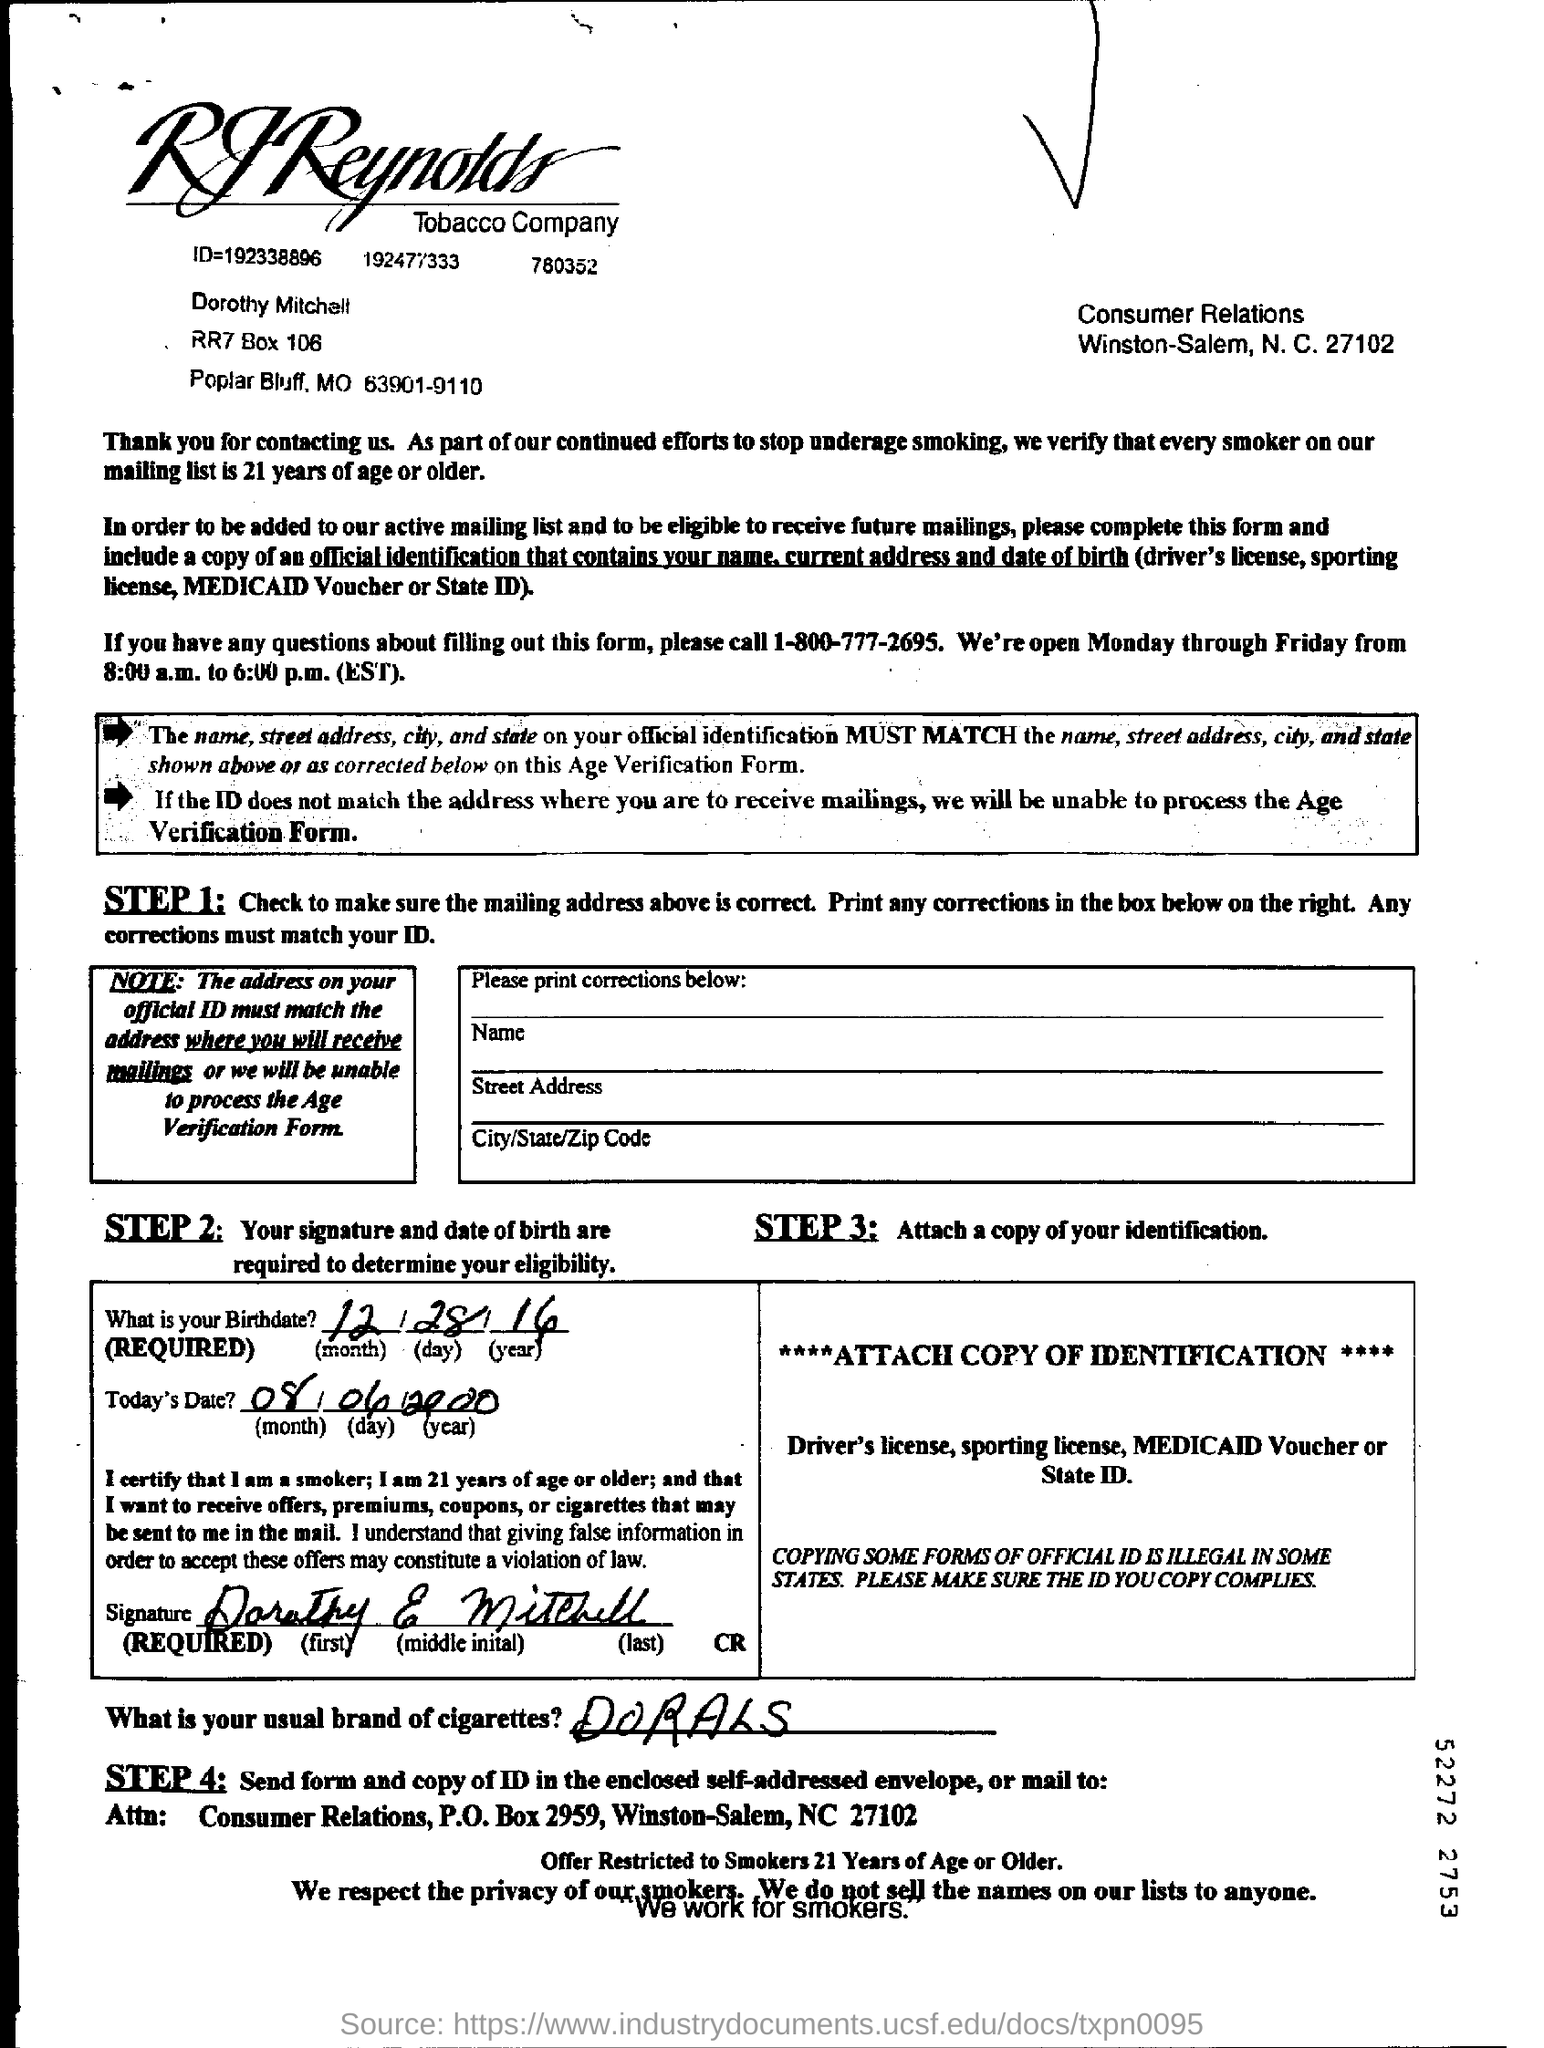Which number to call about questions on filling out this form?
Make the answer very short. 1-800-777-2695. Which is the usual brand of cigarettes mentioned?
Provide a succinct answer. DORALS. What is the birthdate mentioned?
Offer a very short reply. 12/28/16. Who has signed the form?
Provide a short and direct response. Dorothy Mitchell. What is STEP 3 printed on the form?
Your answer should be compact. Attach a copy of your identification. 